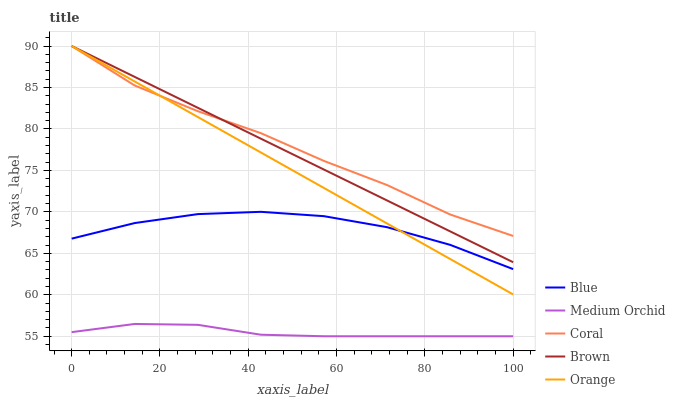Does Medium Orchid have the minimum area under the curve?
Answer yes or no. Yes. Does Coral have the maximum area under the curve?
Answer yes or no. Yes. Does Brown have the minimum area under the curve?
Answer yes or no. No. Does Brown have the maximum area under the curve?
Answer yes or no. No. Is Brown the smoothest?
Answer yes or no. Yes. Is Coral the roughest?
Answer yes or no. Yes. Is Coral the smoothest?
Answer yes or no. No. Is Brown the roughest?
Answer yes or no. No. Does Medium Orchid have the lowest value?
Answer yes or no. Yes. Does Brown have the lowest value?
Answer yes or no. No. Does Orange have the highest value?
Answer yes or no. Yes. Does Medium Orchid have the highest value?
Answer yes or no. No. Is Medium Orchid less than Orange?
Answer yes or no. Yes. Is Brown greater than Blue?
Answer yes or no. Yes. Does Brown intersect Coral?
Answer yes or no. Yes. Is Brown less than Coral?
Answer yes or no. No. Is Brown greater than Coral?
Answer yes or no. No. Does Medium Orchid intersect Orange?
Answer yes or no. No. 